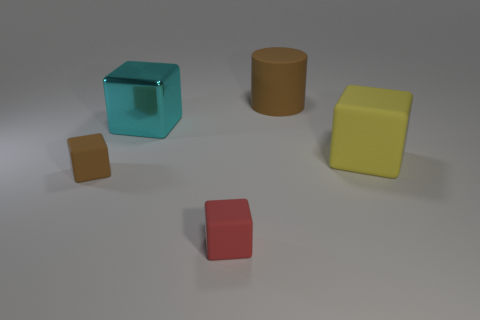Are there any other things that have the same material as the large cyan thing?
Your response must be concise. No. Is the brown thing that is right of the large shiny block made of the same material as the big cyan thing?
Offer a very short reply. No. Is the number of big brown matte cylinders that are in front of the tiny brown cube the same as the number of cyan metallic things that are left of the large cyan shiny block?
Offer a very short reply. Yes. There is a red thing that is the same shape as the large cyan object; what is it made of?
Your answer should be very brief. Rubber. There is a cube that is to the right of the brown thing that is on the right side of the small brown block; are there any big shiny cubes on the right side of it?
Provide a succinct answer. No. There is a small matte object right of the cyan shiny block; is it the same shape as the brown rubber thing that is on the left side of the cyan metallic object?
Your answer should be very brief. Yes. Are there more cyan metallic cubes that are left of the tiny red matte thing than gray shiny cylinders?
Your response must be concise. Yes. What number of objects are cyan shiny objects or small red blocks?
Your answer should be compact. 2. The large shiny cube is what color?
Provide a succinct answer. Cyan. How many other objects are there of the same color as the matte cylinder?
Offer a terse response. 1. 